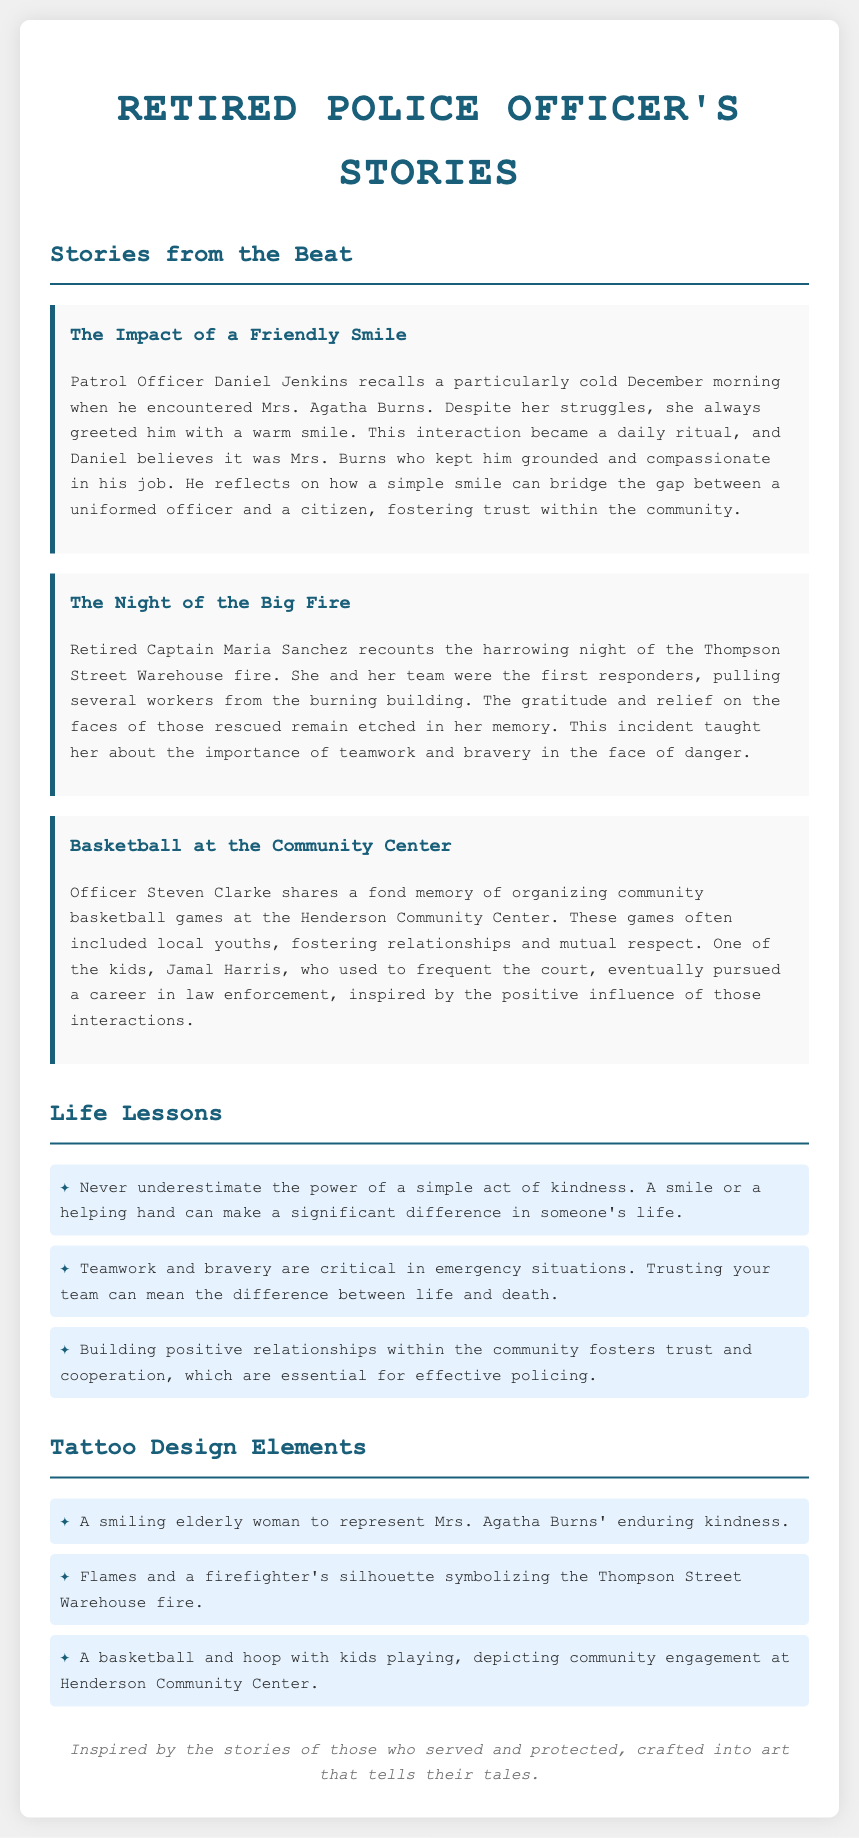What does Mrs. Agatha Burns represent in Officer Daniel Jenkins' story? Mrs. Agatha Burns represents enduring kindness through her warm smile, which impacted Officer Jenkins' outlook during his service.
Answer: Enduring kindness What event is Captain Maria Sanchez recounting? The event is the Thompson Street Warehouse fire, which involved heroic rescues and teamwork.
Answer: Thompson Street Warehouse fire Who was inspired to pursue a career in law enforcement? Jamal Harris, a local youth who participated in community basketball games, was inspired by the positive influence of the officers.
Answer: Jamal Harris How many life lessons are mentioned in the document? There are three life lessons outlined that reflect the overall messages from the officers' stories.
Answer: Three What symbol represents the incident of the Thompson Street Warehouse fire in the tattoo design elements? The symbol representing the fire incident is a firefighter's silhouette along with flames.
Answer: Firefighter's silhouette and flames What does the tattoo design element depicting kids playing stand for? It stands for community engagement at the Henderson Community Center through basketball games organized by the officers.
Answer: Community engagement What is the title of the document? The title encapsulates the theme of the content, focusing on the stories shared by a retired police officer.
Answer: Retired Police Officer's Stories Which officer recalls organizing basketball games? Officer Steven Clarke recounted his experiences in organizing community basketball games.
Answer: Officer Steven Clarke 